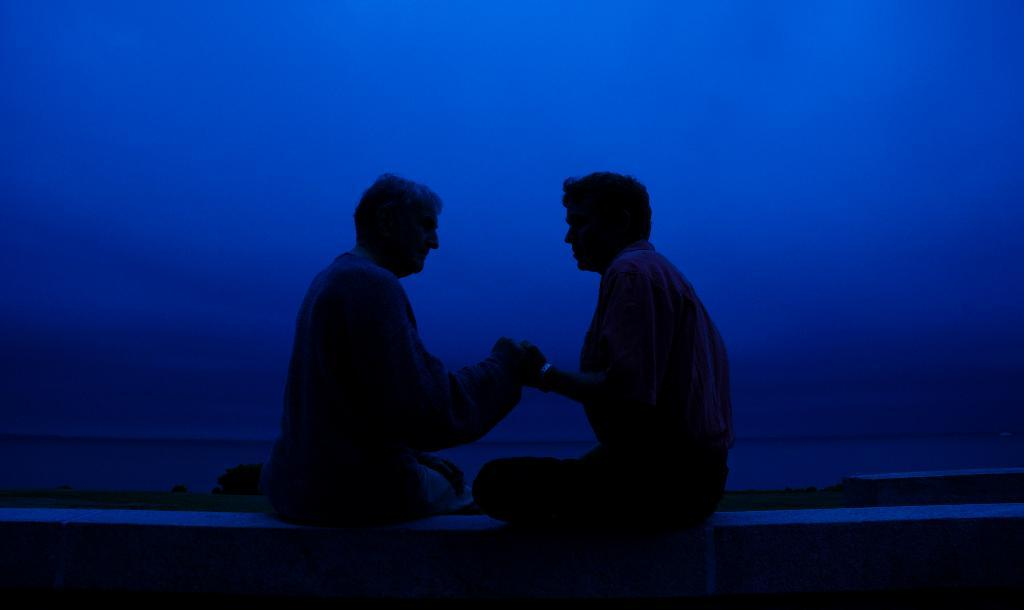How many people are in the image? There are two persons in the image. What are the two persons doing in the image? The two persons are sitting on a wall. What color is the background of the image? The background of the image is blue. What suggestion does the self-aware society make in the image? There is no suggestion or self-aware society present in the image; it features two persons sitting on a wall with a blue background. 